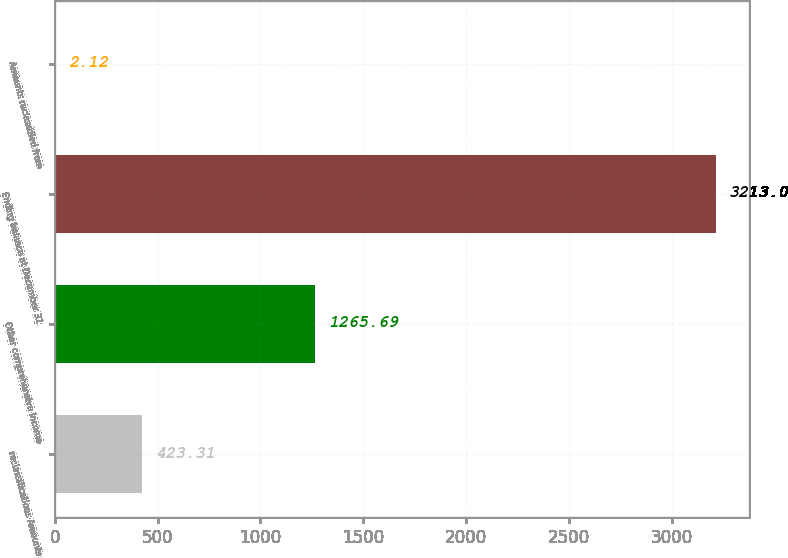Convert chart. <chart><loc_0><loc_0><loc_500><loc_500><bar_chart><fcel>reclassifications Amounts<fcel>Other comprehensive income<fcel>Ending balance at December 31<fcel>Amounts reclassified from<nl><fcel>423.31<fcel>1265.69<fcel>3213<fcel>2.12<nl></chart> 